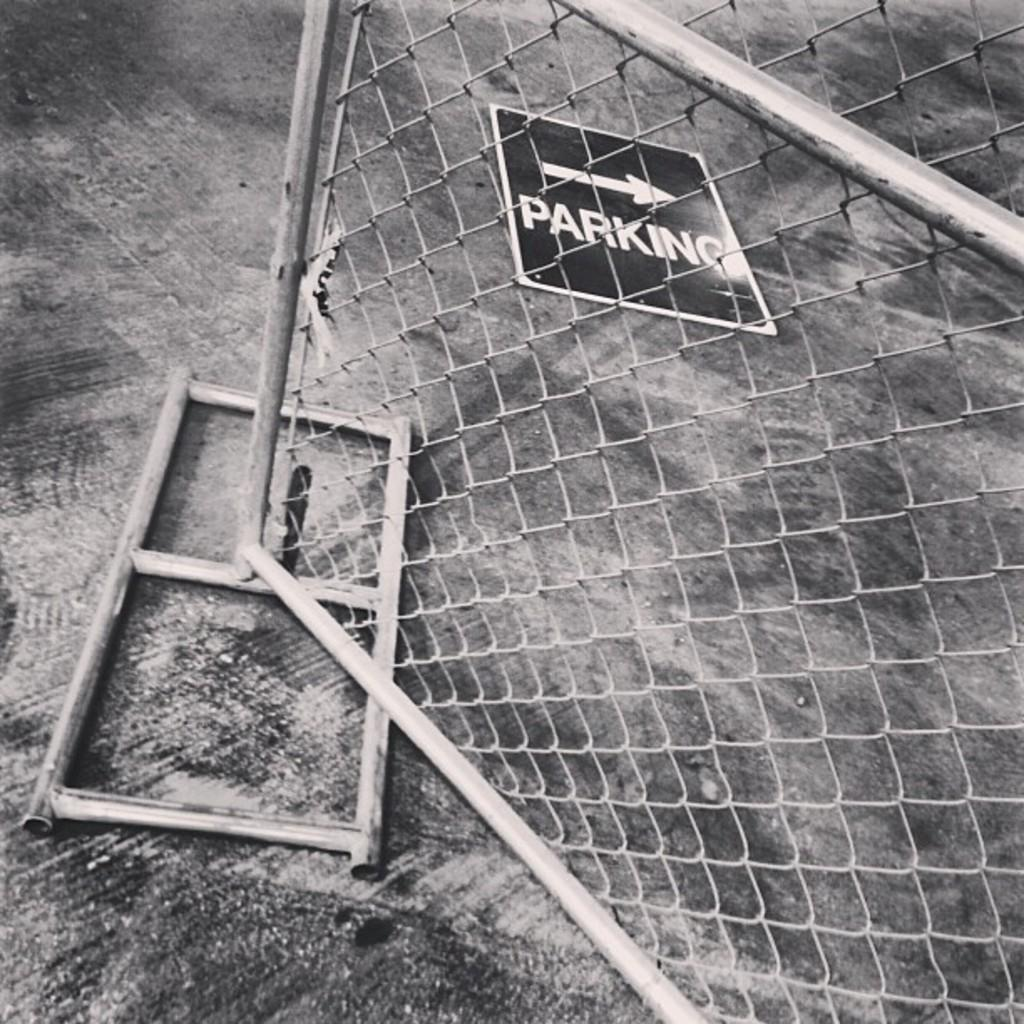What type of structure can be seen in the image? There is fencing in the image. What else can be seen in the background of the image? There is a board visible in the background of the image. What color scheme is used in the image? The image is in black and white. Can you see a yak using an umbrella with a wing in the image? No, there is no yak, umbrella, or wing present in the image. 